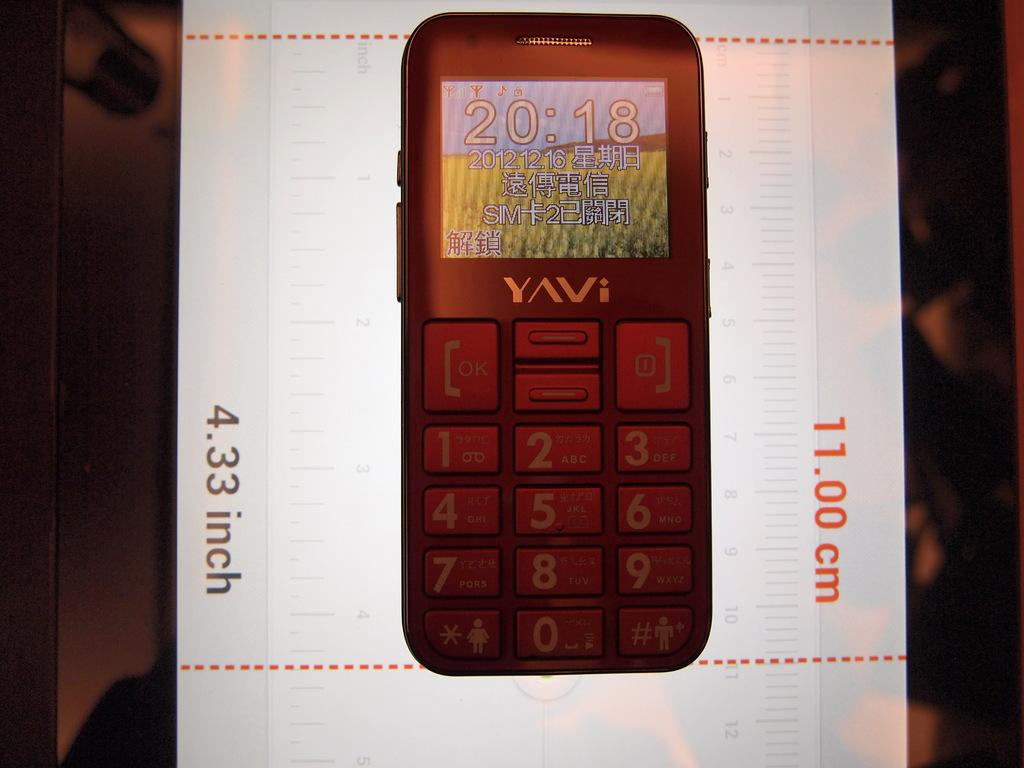<image>
Render a clear and concise summary of the photo. A Yavi cellphone is 4.33 inches tall or 11.00 cm. 